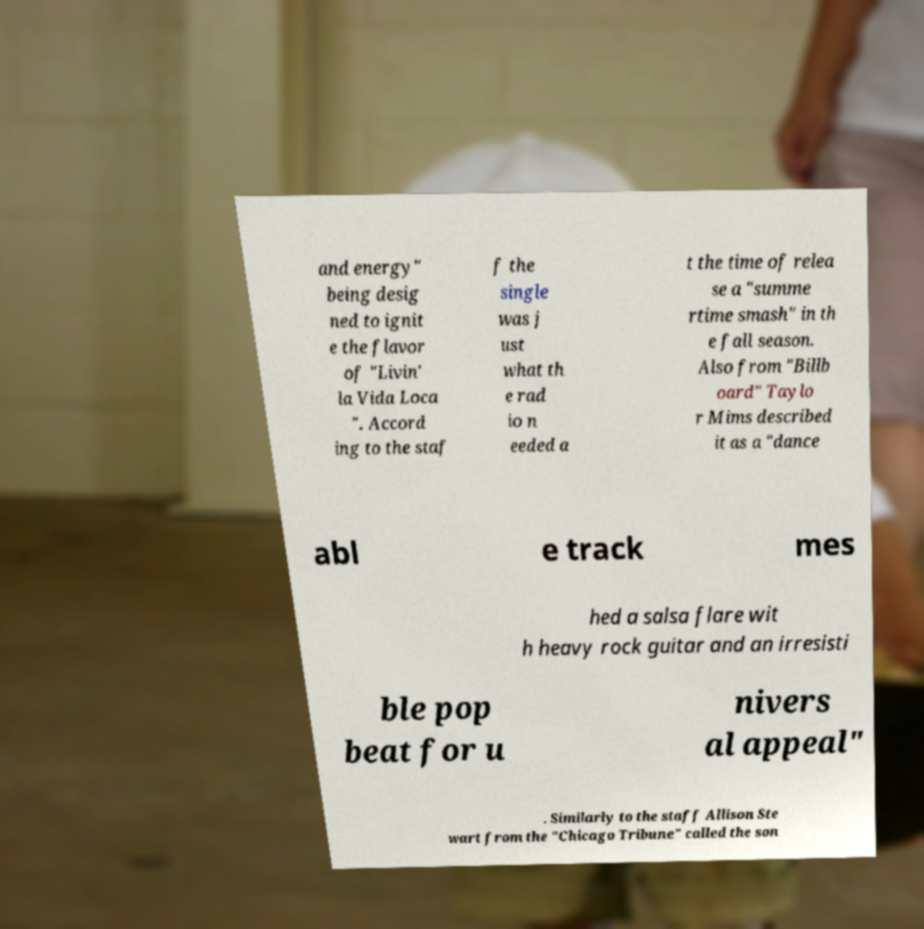There's text embedded in this image that I need extracted. Can you transcribe it verbatim? and energy" being desig ned to ignit e the flavor of "Livin' la Vida Loca ". Accord ing to the staf f the single was j ust what th e rad io n eeded a t the time of relea se a "summe rtime smash" in th e fall season. Also from "Billb oard" Taylo r Mims described it as a "dance abl e track mes hed a salsa flare wit h heavy rock guitar and an irresisti ble pop beat for u nivers al appeal" . Similarly to the staff Allison Ste wart from the "Chicago Tribune" called the son 